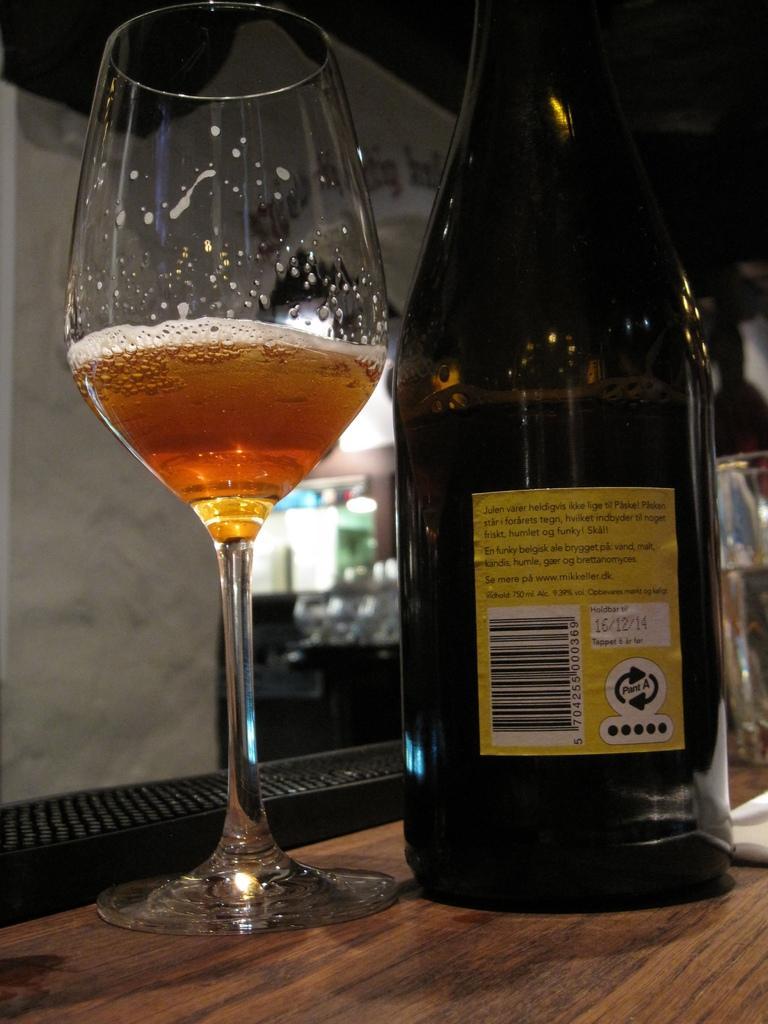Could you give a brief overview of what you see in this image? This is a zoomed in picture. In the foreground we can see a glass of drink, a glass bottle and some other items are placed on the top of the table. In the background we can see the lights and many other objects. 